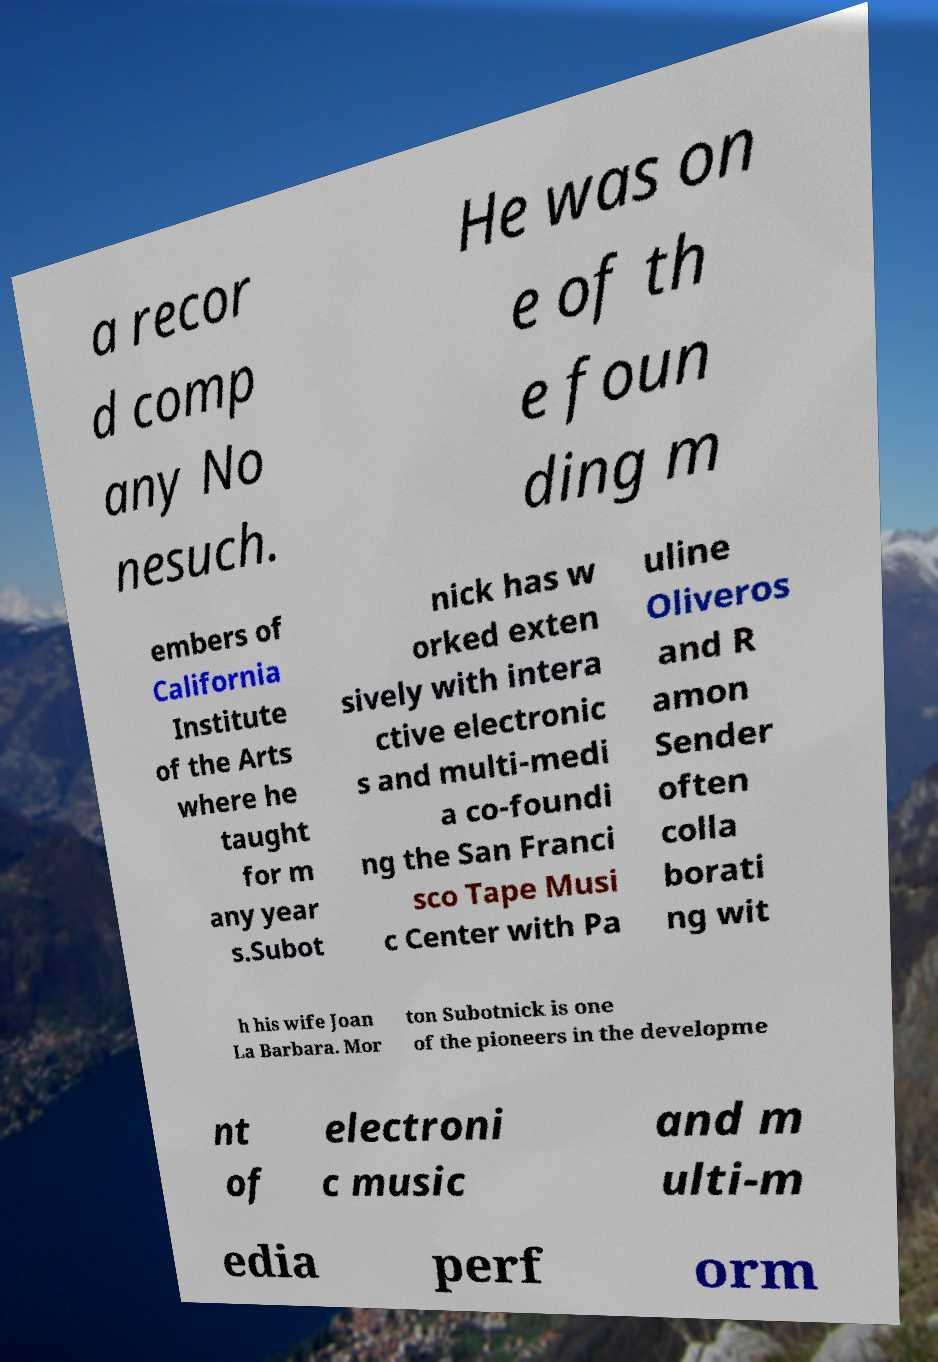What messages or text are displayed in this image? I need them in a readable, typed format. a recor d comp any No nesuch. He was on e of th e foun ding m embers of California Institute of the Arts where he taught for m any year s.Subot nick has w orked exten sively with intera ctive electronic s and multi-medi a co-foundi ng the San Franci sco Tape Musi c Center with Pa uline Oliveros and R amon Sender often colla borati ng wit h his wife Joan La Barbara. Mor ton Subotnick is one of the pioneers in the developme nt of electroni c music and m ulti-m edia perf orm 